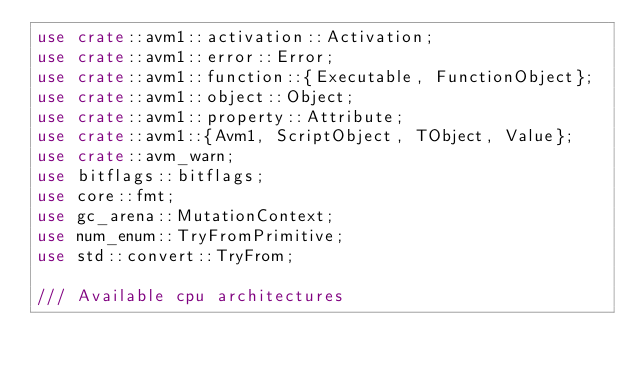Convert code to text. <code><loc_0><loc_0><loc_500><loc_500><_Rust_>use crate::avm1::activation::Activation;
use crate::avm1::error::Error;
use crate::avm1::function::{Executable, FunctionObject};
use crate::avm1::object::Object;
use crate::avm1::property::Attribute;
use crate::avm1::{Avm1, ScriptObject, TObject, Value};
use crate::avm_warn;
use bitflags::bitflags;
use core::fmt;
use gc_arena::MutationContext;
use num_enum::TryFromPrimitive;
use std::convert::TryFrom;

/// Available cpu architectures</code> 